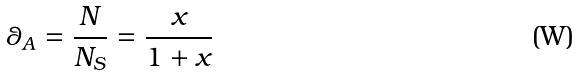<formula> <loc_0><loc_0><loc_500><loc_500>\theta _ { A } = \frac { N } { N _ { S } } = \frac { x } { 1 + x }</formula> 